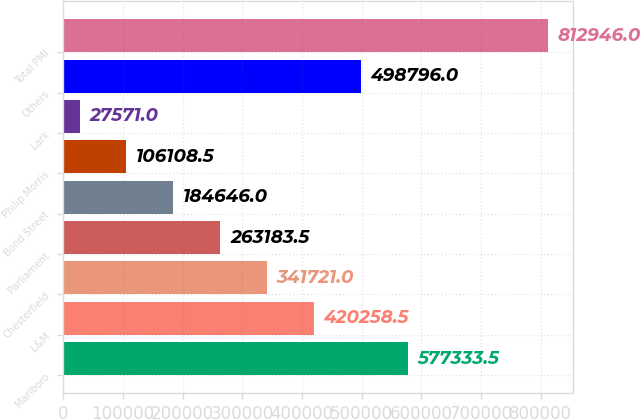<chart> <loc_0><loc_0><loc_500><loc_500><bar_chart><fcel>Marlboro<fcel>L&M<fcel>Chesterfield<fcel>Parliament<fcel>Bond Street<fcel>Philip Morris<fcel>Lark<fcel>Others<fcel>Total PMI<nl><fcel>577334<fcel>420258<fcel>341721<fcel>263184<fcel>184646<fcel>106108<fcel>27571<fcel>498796<fcel>812946<nl></chart> 